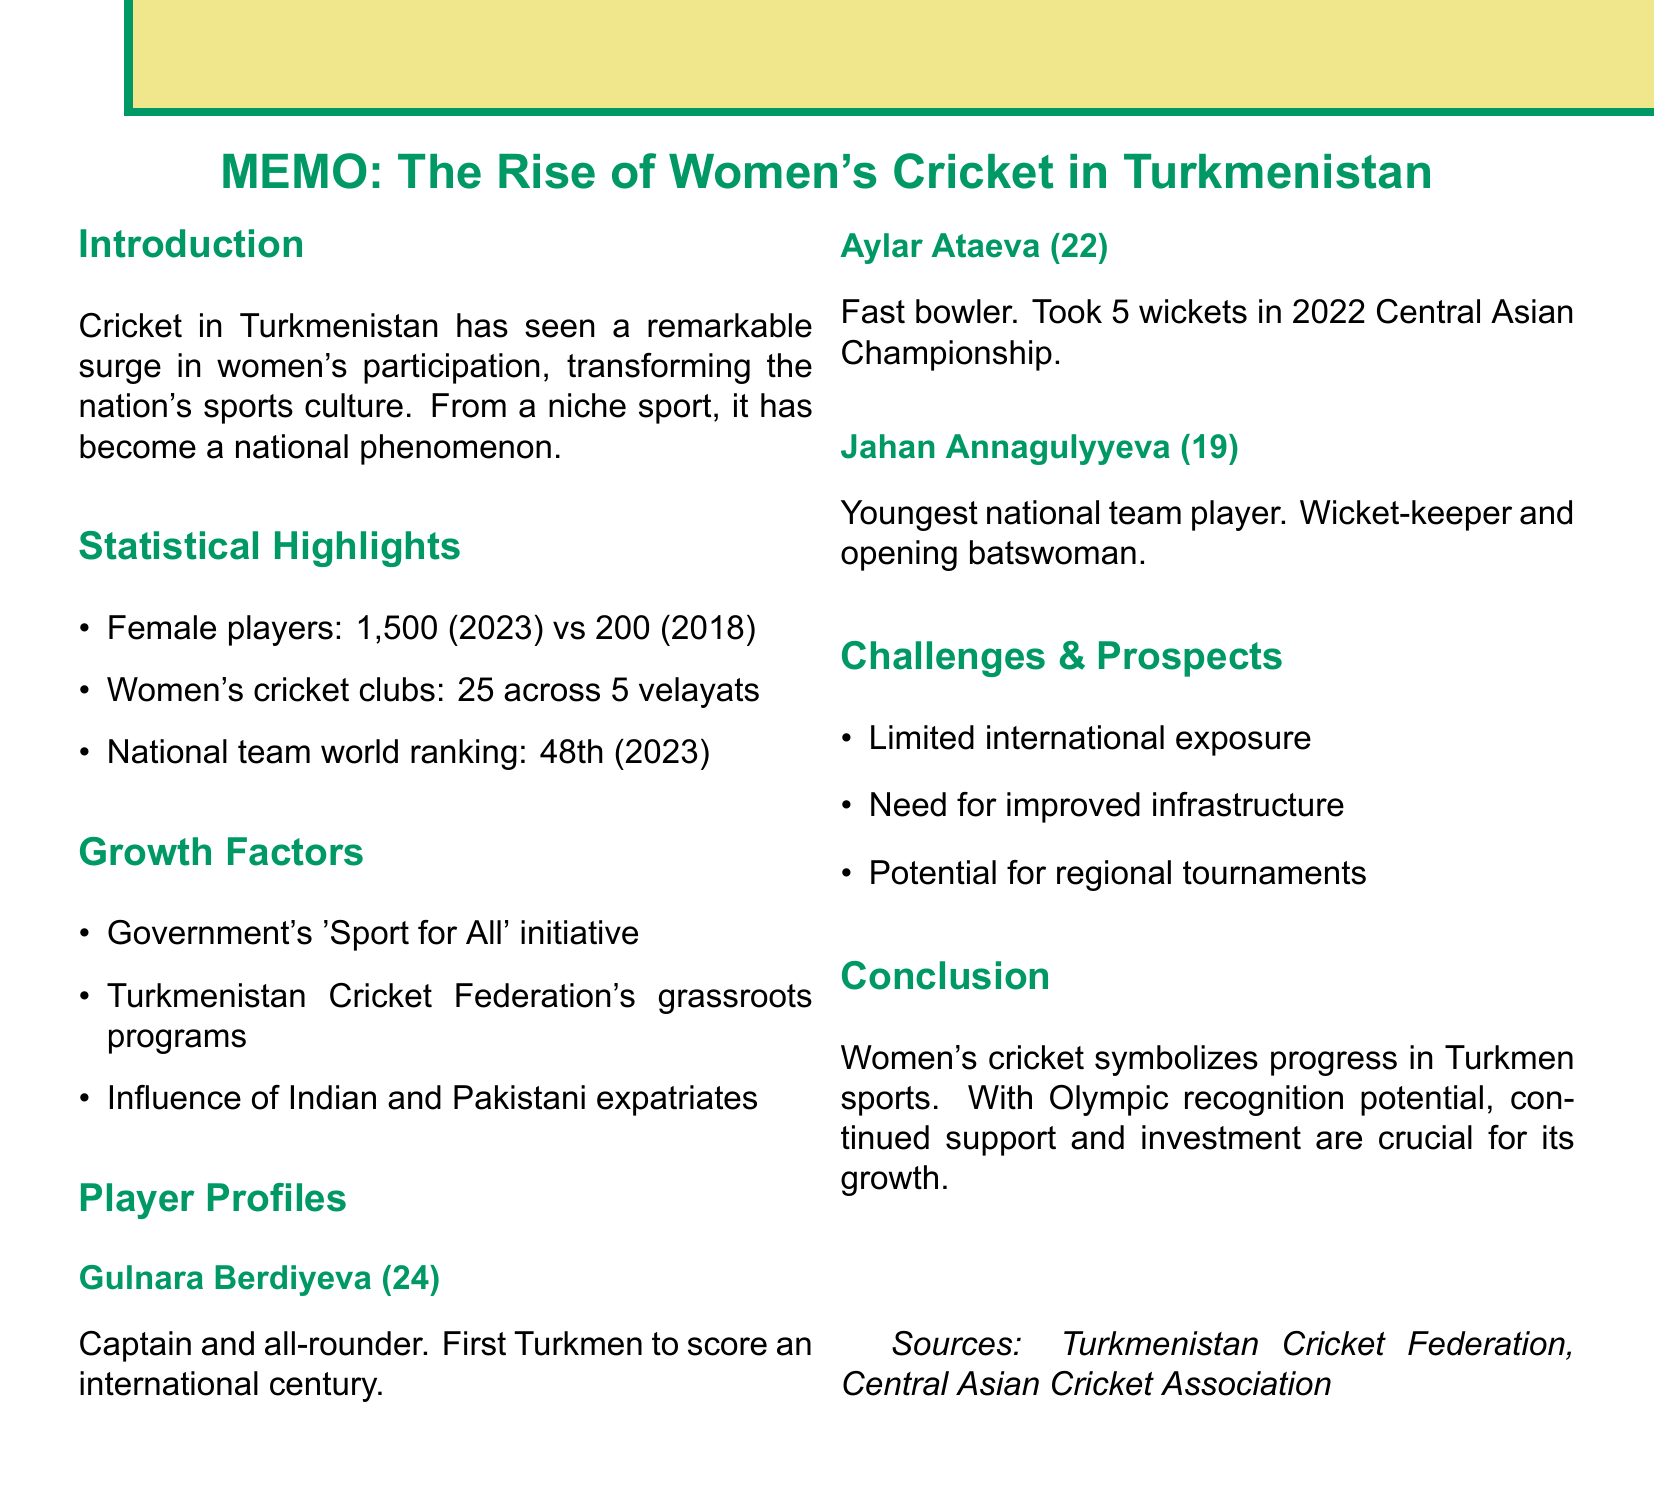what is the title of the memo? The title is the primary focus of the document and is directly stated at the top.
Answer: The Flourishing of Women's Cricket in Turkmenistan: A National Phenomenon how many registered female players were there in 2023? This information is found in the statistical overview section of the document.
Answer: 1,500 what significant achievement did Gulnara Berdiyeva accomplish? This refers to the specific player profile and their highlight in women's cricket.
Answer: First Turkmen cricketer to score a century in an international match what was Turkmenistan's national team world ranking in 2018? The ranking comparison between 2023 and 2018 is mentioned in the statistics.
Answer: Unranked which age group does Jahan Annagulyyeva belong to? The age of the player is specified in their profile.
Answer: 19 what is one of the challenges facing women's cricket in Turkmenistan? The challenges section lists potential hurdles for the sport's growth.
Answer: Limited international exposure which governmental initiative supports women's sports in Turkmenistan? This relates to the factors that contribute to the growth of women's cricket.
Answer: Sport for All how many women's cricket clubs are there in Turkmenistan? This statistic highlights the growth of women's cricket at a community level.
Answer: 25 what is the significance of women's cricket as stated in the conclusion? The conclusion part of the document emphasizes the cultural relevance of women's cricket.
Answer: A symbol of progress in Turkmen sports 